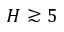<formula> <loc_0><loc_0><loc_500><loc_500>H \gtrsim 5</formula> 